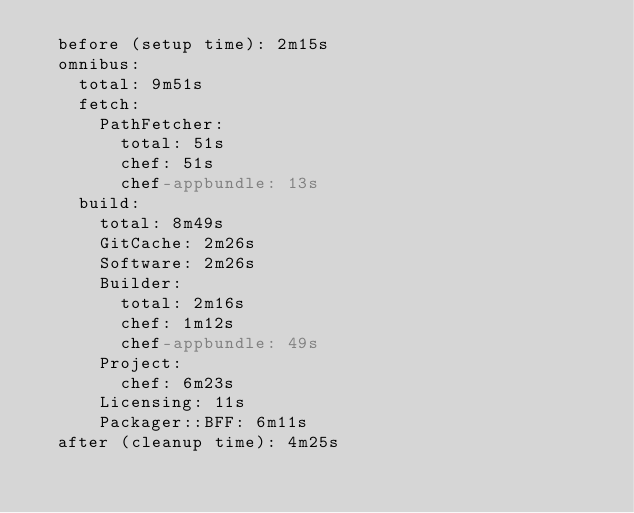Convert code to text. <code><loc_0><loc_0><loc_500><loc_500><_YAML_>  before (setup time): 2m15s
  omnibus:
    total: 9m51s
    fetch:
      PathFetcher:
        total: 51s
        chef: 51s
        chef-appbundle: 13s
    build:
      total: 8m49s
      GitCache: 2m26s
      Software: 2m26s
      Builder:
        total: 2m16s
        chef: 1m12s
        chef-appbundle: 49s
      Project:
        chef: 6m23s
      Licensing: 11s
      Packager::BFF: 6m11s
  after (cleanup time): 4m25s
</code> 